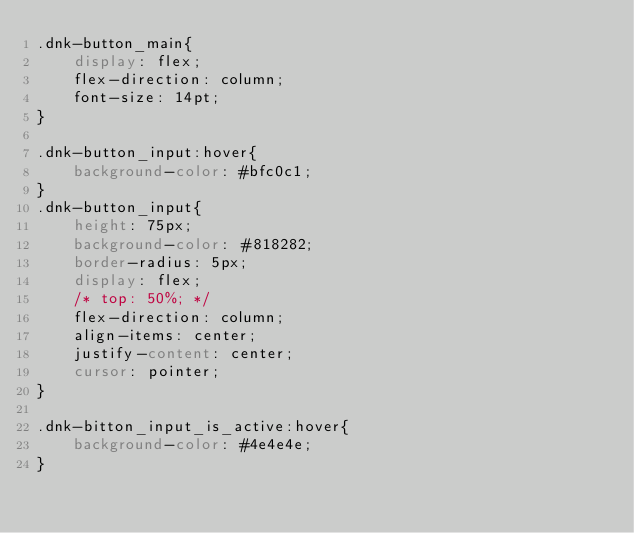Convert code to text. <code><loc_0><loc_0><loc_500><loc_500><_CSS_>.dnk-button_main{
    display: flex;
    flex-direction: column;
    font-size: 14pt;
}

.dnk-button_input:hover{
    background-color: #bfc0c1;
}
.dnk-button_input{
    height: 75px;
    background-color: #818282;
    border-radius: 5px;
    display: flex;
    /* top: 50%; */
    flex-direction: column;
    align-items: center;
    justify-content: center;
    cursor: pointer;
}

.dnk-bitton_input_is_active:hover{
    background-color: #4e4e4e;
}</code> 